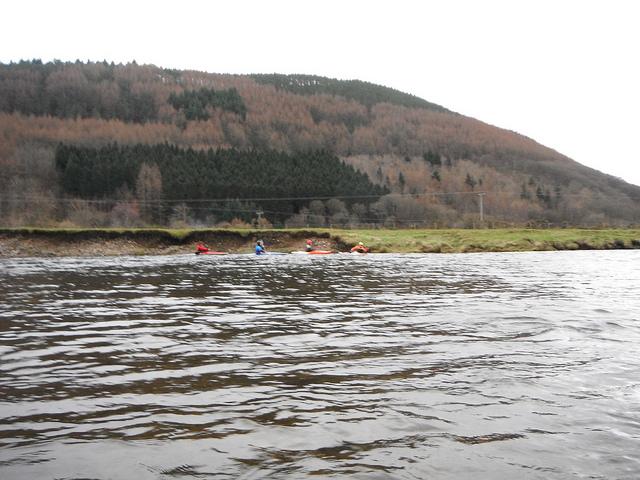Why is the water rippled?
Quick response, please. Wind. Do you think they are boat racing?
Quick response, please. No. How many small waves are in the lake?
Quick response, please. 0. Are they on river or a lake?
Keep it brief. River. 